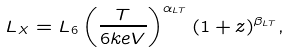Convert formula to latex. <formula><loc_0><loc_0><loc_500><loc_500>L _ { X } = L _ { 6 } \left ( \frac { T } { 6 k e V } \right ) ^ { \alpha _ { L T } } ( 1 + z ) ^ { \beta _ { L T } } ,</formula> 